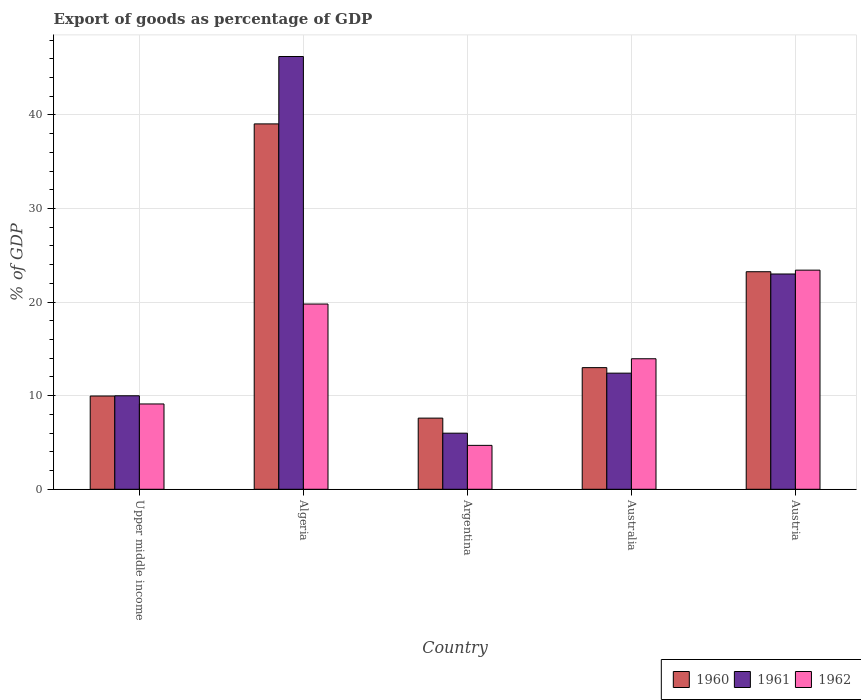How many different coloured bars are there?
Keep it short and to the point. 3. How many groups of bars are there?
Your response must be concise. 5. Are the number of bars per tick equal to the number of legend labels?
Your response must be concise. Yes. Are the number of bars on each tick of the X-axis equal?
Provide a succinct answer. Yes. How many bars are there on the 1st tick from the left?
Ensure brevity in your answer.  3. How many bars are there on the 4th tick from the right?
Your response must be concise. 3. In how many cases, is the number of bars for a given country not equal to the number of legend labels?
Make the answer very short. 0. What is the export of goods as percentage of GDP in 1960 in Upper middle income?
Your answer should be very brief. 9.97. Across all countries, what is the maximum export of goods as percentage of GDP in 1962?
Make the answer very short. 23.42. Across all countries, what is the minimum export of goods as percentage of GDP in 1961?
Make the answer very short. 5.99. In which country was the export of goods as percentage of GDP in 1961 maximum?
Your answer should be very brief. Algeria. In which country was the export of goods as percentage of GDP in 1960 minimum?
Make the answer very short. Argentina. What is the total export of goods as percentage of GDP in 1961 in the graph?
Offer a terse response. 97.64. What is the difference between the export of goods as percentage of GDP in 1962 in Argentina and that in Australia?
Offer a very short reply. -9.25. What is the difference between the export of goods as percentage of GDP in 1961 in Australia and the export of goods as percentage of GDP in 1960 in Austria?
Give a very brief answer. -10.84. What is the average export of goods as percentage of GDP in 1962 per country?
Your answer should be very brief. 14.19. What is the difference between the export of goods as percentage of GDP of/in 1962 and export of goods as percentage of GDP of/in 1961 in Argentina?
Offer a terse response. -1.3. What is the ratio of the export of goods as percentage of GDP in 1961 in Algeria to that in Austria?
Your answer should be very brief. 2.01. Is the export of goods as percentage of GDP in 1961 in Algeria less than that in Upper middle income?
Your answer should be very brief. No. What is the difference between the highest and the second highest export of goods as percentage of GDP in 1960?
Your answer should be compact. 10.25. What is the difference between the highest and the lowest export of goods as percentage of GDP in 1961?
Make the answer very short. 40.25. Is the sum of the export of goods as percentage of GDP in 1961 in Australia and Upper middle income greater than the maximum export of goods as percentage of GDP in 1962 across all countries?
Give a very brief answer. No. What does the 2nd bar from the left in Austria represents?
Ensure brevity in your answer.  1961. How many bars are there?
Your answer should be compact. 15. How many countries are there in the graph?
Give a very brief answer. 5. Does the graph contain any zero values?
Offer a terse response. No. Does the graph contain grids?
Provide a succinct answer. Yes. How are the legend labels stacked?
Your answer should be very brief. Horizontal. What is the title of the graph?
Your answer should be compact. Export of goods as percentage of GDP. Does "1978" appear as one of the legend labels in the graph?
Offer a very short reply. No. What is the label or title of the Y-axis?
Provide a short and direct response. % of GDP. What is the % of GDP of 1960 in Upper middle income?
Your answer should be very brief. 9.97. What is the % of GDP of 1961 in Upper middle income?
Provide a short and direct response. 9.99. What is the % of GDP in 1962 in Upper middle income?
Your response must be concise. 9.12. What is the % of GDP in 1960 in Algeria?
Ensure brevity in your answer.  39.04. What is the % of GDP in 1961 in Algeria?
Your response must be concise. 46.24. What is the % of GDP of 1962 in Algeria?
Provide a succinct answer. 19.79. What is the % of GDP in 1960 in Argentina?
Make the answer very short. 7.6. What is the % of GDP of 1961 in Argentina?
Give a very brief answer. 5.99. What is the % of GDP in 1962 in Argentina?
Ensure brevity in your answer.  4.69. What is the % of GDP in 1960 in Australia?
Your response must be concise. 13. What is the % of GDP in 1961 in Australia?
Your response must be concise. 12.41. What is the % of GDP in 1962 in Australia?
Your answer should be very brief. 13.95. What is the % of GDP of 1960 in Austria?
Make the answer very short. 23.25. What is the % of GDP in 1961 in Austria?
Provide a succinct answer. 23.01. What is the % of GDP in 1962 in Austria?
Your response must be concise. 23.42. Across all countries, what is the maximum % of GDP of 1960?
Provide a short and direct response. 39.04. Across all countries, what is the maximum % of GDP in 1961?
Your answer should be very brief. 46.24. Across all countries, what is the maximum % of GDP of 1962?
Provide a short and direct response. 23.42. Across all countries, what is the minimum % of GDP of 1960?
Your response must be concise. 7.6. Across all countries, what is the minimum % of GDP in 1961?
Keep it short and to the point. 5.99. Across all countries, what is the minimum % of GDP of 1962?
Make the answer very short. 4.69. What is the total % of GDP of 1960 in the graph?
Keep it short and to the point. 92.86. What is the total % of GDP of 1961 in the graph?
Make the answer very short. 97.64. What is the total % of GDP in 1962 in the graph?
Your answer should be compact. 70.97. What is the difference between the % of GDP in 1960 in Upper middle income and that in Algeria?
Your answer should be very brief. -29.08. What is the difference between the % of GDP of 1961 in Upper middle income and that in Algeria?
Offer a terse response. -36.25. What is the difference between the % of GDP of 1962 in Upper middle income and that in Algeria?
Offer a very short reply. -10.68. What is the difference between the % of GDP in 1960 in Upper middle income and that in Argentina?
Keep it short and to the point. 2.36. What is the difference between the % of GDP in 1961 in Upper middle income and that in Argentina?
Your response must be concise. 4. What is the difference between the % of GDP of 1962 in Upper middle income and that in Argentina?
Offer a very short reply. 4.43. What is the difference between the % of GDP in 1960 in Upper middle income and that in Australia?
Ensure brevity in your answer.  -3.03. What is the difference between the % of GDP of 1961 in Upper middle income and that in Australia?
Your response must be concise. -2.42. What is the difference between the % of GDP in 1962 in Upper middle income and that in Australia?
Give a very brief answer. -4.83. What is the difference between the % of GDP in 1960 in Upper middle income and that in Austria?
Your answer should be compact. -13.28. What is the difference between the % of GDP of 1961 in Upper middle income and that in Austria?
Your answer should be very brief. -13.01. What is the difference between the % of GDP in 1962 in Upper middle income and that in Austria?
Keep it short and to the point. -14.3. What is the difference between the % of GDP of 1960 in Algeria and that in Argentina?
Keep it short and to the point. 31.44. What is the difference between the % of GDP of 1961 in Algeria and that in Argentina?
Give a very brief answer. 40.25. What is the difference between the % of GDP of 1962 in Algeria and that in Argentina?
Your response must be concise. 15.1. What is the difference between the % of GDP of 1960 in Algeria and that in Australia?
Give a very brief answer. 26.04. What is the difference between the % of GDP in 1961 in Algeria and that in Australia?
Provide a succinct answer. 33.84. What is the difference between the % of GDP in 1962 in Algeria and that in Australia?
Your response must be concise. 5.85. What is the difference between the % of GDP in 1960 in Algeria and that in Austria?
Keep it short and to the point. 15.8. What is the difference between the % of GDP of 1961 in Algeria and that in Austria?
Your answer should be compact. 23.24. What is the difference between the % of GDP in 1962 in Algeria and that in Austria?
Offer a very short reply. -3.62. What is the difference between the % of GDP in 1960 in Argentina and that in Australia?
Provide a succinct answer. -5.39. What is the difference between the % of GDP of 1961 in Argentina and that in Australia?
Offer a terse response. -6.41. What is the difference between the % of GDP in 1962 in Argentina and that in Australia?
Keep it short and to the point. -9.25. What is the difference between the % of GDP of 1960 in Argentina and that in Austria?
Provide a succinct answer. -15.64. What is the difference between the % of GDP in 1961 in Argentina and that in Austria?
Make the answer very short. -17.01. What is the difference between the % of GDP of 1962 in Argentina and that in Austria?
Make the answer very short. -18.72. What is the difference between the % of GDP of 1960 in Australia and that in Austria?
Give a very brief answer. -10.25. What is the difference between the % of GDP in 1961 in Australia and that in Austria?
Your answer should be very brief. -10.6. What is the difference between the % of GDP in 1962 in Australia and that in Austria?
Keep it short and to the point. -9.47. What is the difference between the % of GDP in 1960 in Upper middle income and the % of GDP in 1961 in Algeria?
Ensure brevity in your answer.  -36.28. What is the difference between the % of GDP in 1960 in Upper middle income and the % of GDP in 1962 in Algeria?
Give a very brief answer. -9.83. What is the difference between the % of GDP of 1961 in Upper middle income and the % of GDP of 1962 in Algeria?
Your response must be concise. -9.8. What is the difference between the % of GDP of 1960 in Upper middle income and the % of GDP of 1961 in Argentina?
Offer a very short reply. 3.97. What is the difference between the % of GDP of 1960 in Upper middle income and the % of GDP of 1962 in Argentina?
Your response must be concise. 5.28. What is the difference between the % of GDP of 1961 in Upper middle income and the % of GDP of 1962 in Argentina?
Keep it short and to the point. 5.3. What is the difference between the % of GDP of 1960 in Upper middle income and the % of GDP of 1961 in Australia?
Your answer should be compact. -2.44. What is the difference between the % of GDP in 1960 in Upper middle income and the % of GDP in 1962 in Australia?
Your answer should be very brief. -3.98. What is the difference between the % of GDP of 1961 in Upper middle income and the % of GDP of 1962 in Australia?
Ensure brevity in your answer.  -3.96. What is the difference between the % of GDP in 1960 in Upper middle income and the % of GDP in 1961 in Austria?
Give a very brief answer. -13.04. What is the difference between the % of GDP of 1960 in Upper middle income and the % of GDP of 1962 in Austria?
Make the answer very short. -13.45. What is the difference between the % of GDP of 1961 in Upper middle income and the % of GDP of 1962 in Austria?
Offer a terse response. -13.43. What is the difference between the % of GDP in 1960 in Algeria and the % of GDP in 1961 in Argentina?
Your response must be concise. 33.05. What is the difference between the % of GDP of 1960 in Algeria and the % of GDP of 1962 in Argentina?
Your response must be concise. 34.35. What is the difference between the % of GDP of 1961 in Algeria and the % of GDP of 1962 in Argentina?
Ensure brevity in your answer.  41.55. What is the difference between the % of GDP of 1960 in Algeria and the % of GDP of 1961 in Australia?
Your answer should be very brief. 26.63. What is the difference between the % of GDP in 1960 in Algeria and the % of GDP in 1962 in Australia?
Your answer should be compact. 25.1. What is the difference between the % of GDP in 1961 in Algeria and the % of GDP in 1962 in Australia?
Provide a succinct answer. 32.3. What is the difference between the % of GDP in 1960 in Algeria and the % of GDP in 1961 in Austria?
Your answer should be very brief. 16.04. What is the difference between the % of GDP in 1960 in Algeria and the % of GDP in 1962 in Austria?
Keep it short and to the point. 15.63. What is the difference between the % of GDP of 1961 in Algeria and the % of GDP of 1962 in Austria?
Offer a very short reply. 22.83. What is the difference between the % of GDP in 1960 in Argentina and the % of GDP in 1961 in Australia?
Your answer should be compact. -4.8. What is the difference between the % of GDP of 1960 in Argentina and the % of GDP of 1962 in Australia?
Ensure brevity in your answer.  -6.34. What is the difference between the % of GDP of 1961 in Argentina and the % of GDP of 1962 in Australia?
Give a very brief answer. -7.95. What is the difference between the % of GDP of 1960 in Argentina and the % of GDP of 1961 in Austria?
Keep it short and to the point. -15.4. What is the difference between the % of GDP of 1960 in Argentina and the % of GDP of 1962 in Austria?
Ensure brevity in your answer.  -15.81. What is the difference between the % of GDP in 1961 in Argentina and the % of GDP in 1962 in Austria?
Your answer should be compact. -17.42. What is the difference between the % of GDP of 1960 in Australia and the % of GDP of 1961 in Austria?
Make the answer very short. -10.01. What is the difference between the % of GDP of 1960 in Australia and the % of GDP of 1962 in Austria?
Make the answer very short. -10.42. What is the difference between the % of GDP of 1961 in Australia and the % of GDP of 1962 in Austria?
Your answer should be very brief. -11.01. What is the average % of GDP in 1960 per country?
Provide a succinct answer. 18.57. What is the average % of GDP in 1961 per country?
Offer a very short reply. 19.53. What is the average % of GDP in 1962 per country?
Keep it short and to the point. 14.19. What is the difference between the % of GDP of 1960 and % of GDP of 1961 in Upper middle income?
Ensure brevity in your answer.  -0.02. What is the difference between the % of GDP in 1960 and % of GDP in 1962 in Upper middle income?
Ensure brevity in your answer.  0.85. What is the difference between the % of GDP in 1961 and % of GDP in 1962 in Upper middle income?
Your answer should be very brief. 0.87. What is the difference between the % of GDP of 1960 and % of GDP of 1961 in Algeria?
Your answer should be very brief. -7.2. What is the difference between the % of GDP of 1960 and % of GDP of 1962 in Algeria?
Make the answer very short. 19.25. What is the difference between the % of GDP of 1961 and % of GDP of 1962 in Algeria?
Provide a short and direct response. 26.45. What is the difference between the % of GDP of 1960 and % of GDP of 1961 in Argentina?
Offer a very short reply. 1.61. What is the difference between the % of GDP of 1960 and % of GDP of 1962 in Argentina?
Keep it short and to the point. 2.91. What is the difference between the % of GDP of 1961 and % of GDP of 1962 in Argentina?
Offer a very short reply. 1.3. What is the difference between the % of GDP of 1960 and % of GDP of 1961 in Australia?
Your answer should be compact. 0.59. What is the difference between the % of GDP of 1960 and % of GDP of 1962 in Australia?
Ensure brevity in your answer.  -0.95. What is the difference between the % of GDP in 1961 and % of GDP in 1962 in Australia?
Keep it short and to the point. -1.54. What is the difference between the % of GDP in 1960 and % of GDP in 1961 in Austria?
Make the answer very short. 0.24. What is the difference between the % of GDP of 1960 and % of GDP of 1962 in Austria?
Give a very brief answer. -0.17. What is the difference between the % of GDP in 1961 and % of GDP in 1962 in Austria?
Keep it short and to the point. -0.41. What is the ratio of the % of GDP of 1960 in Upper middle income to that in Algeria?
Provide a short and direct response. 0.26. What is the ratio of the % of GDP of 1961 in Upper middle income to that in Algeria?
Offer a terse response. 0.22. What is the ratio of the % of GDP in 1962 in Upper middle income to that in Algeria?
Keep it short and to the point. 0.46. What is the ratio of the % of GDP of 1960 in Upper middle income to that in Argentina?
Ensure brevity in your answer.  1.31. What is the ratio of the % of GDP in 1961 in Upper middle income to that in Argentina?
Provide a succinct answer. 1.67. What is the ratio of the % of GDP of 1962 in Upper middle income to that in Argentina?
Keep it short and to the point. 1.94. What is the ratio of the % of GDP of 1960 in Upper middle income to that in Australia?
Provide a succinct answer. 0.77. What is the ratio of the % of GDP in 1961 in Upper middle income to that in Australia?
Offer a very short reply. 0.81. What is the ratio of the % of GDP in 1962 in Upper middle income to that in Australia?
Offer a very short reply. 0.65. What is the ratio of the % of GDP in 1960 in Upper middle income to that in Austria?
Offer a very short reply. 0.43. What is the ratio of the % of GDP in 1961 in Upper middle income to that in Austria?
Your response must be concise. 0.43. What is the ratio of the % of GDP in 1962 in Upper middle income to that in Austria?
Provide a short and direct response. 0.39. What is the ratio of the % of GDP in 1960 in Algeria to that in Argentina?
Provide a succinct answer. 5.13. What is the ratio of the % of GDP in 1961 in Algeria to that in Argentina?
Keep it short and to the point. 7.71. What is the ratio of the % of GDP of 1962 in Algeria to that in Argentina?
Your answer should be very brief. 4.22. What is the ratio of the % of GDP in 1960 in Algeria to that in Australia?
Keep it short and to the point. 3. What is the ratio of the % of GDP in 1961 in Algeria to that in Australia?
Offer a terse response. 3.73. What is the ratio of the % of GDP of 1962 in Algeria to that in Australia?
Offer a terse response. 1.42. What is the ratio of the % of GDP of 1960 in Algeria to that in Austria?
Provide a succinct answer. 1.68. What is the ratio of the % of GDP of 1961 in Algeria to that in Austria?
Your answer should be compact. 2.01. What is the ratio of the % of GDP of 1962 in Algeria to that in Austria?
Your answer should be compact. 0.85. What is the ratio of the % of GDP of 1960 in Argentina to that in Australia?
Your answer should be compact. 0.58. What is the ratio of the % of GDP of 1961 in Argentina to that in Australia?
Make the answer very short. 0.48. What is the ratio of the % of GDP in 1962 in Argentina to that in Australia?
Provide a short and direct response. 0.34. What is the ratio of the % of GDP of 1960 in Argentina to that in Austria?
Ensure brevity in your answer.  0.33. What is the ratio of the % of GDP in 1961 in Argentina to that in Austria?
Your response must be concise. 0.26. What is the ratio of the % of GDP of 1962 in Argentina to that in Austria?
Give a very brief answer. 0.2. What is the ratio of the % of GDP of 1960 in Australia to that in Austria?
Provide a succinct answer. 0.56. What is the ratio of the % of GDP of 1961 in Australia to that in Austria?
Ensure brevity in your answer.  0.54. What is the ratio of the % of GDP of 1962 in Australia to that in Austria?
Make the answer very short. 0.6. What is the difference between the highest and the second highest % of GDP in 1960?
Make the answer very short. 15.8. What is the difference between the highest and the second highest % of GDP of 1961?
Offer a terse response. 23.24. What is the difference between the highest and the second highest % of GDP of 1962?
Your answer should be very brief. 3.62. What is the difference between the highest and the lowest % of GDP in 1960?
Give a very brief answer. 31.44. What is the difference between the highest and the lowest % of GDP in 1961?
Offer a very short reply. 40.25. What is the difference between the highest and the lowest % of GDP of 1962?
Your response must be concise. 18.72. 